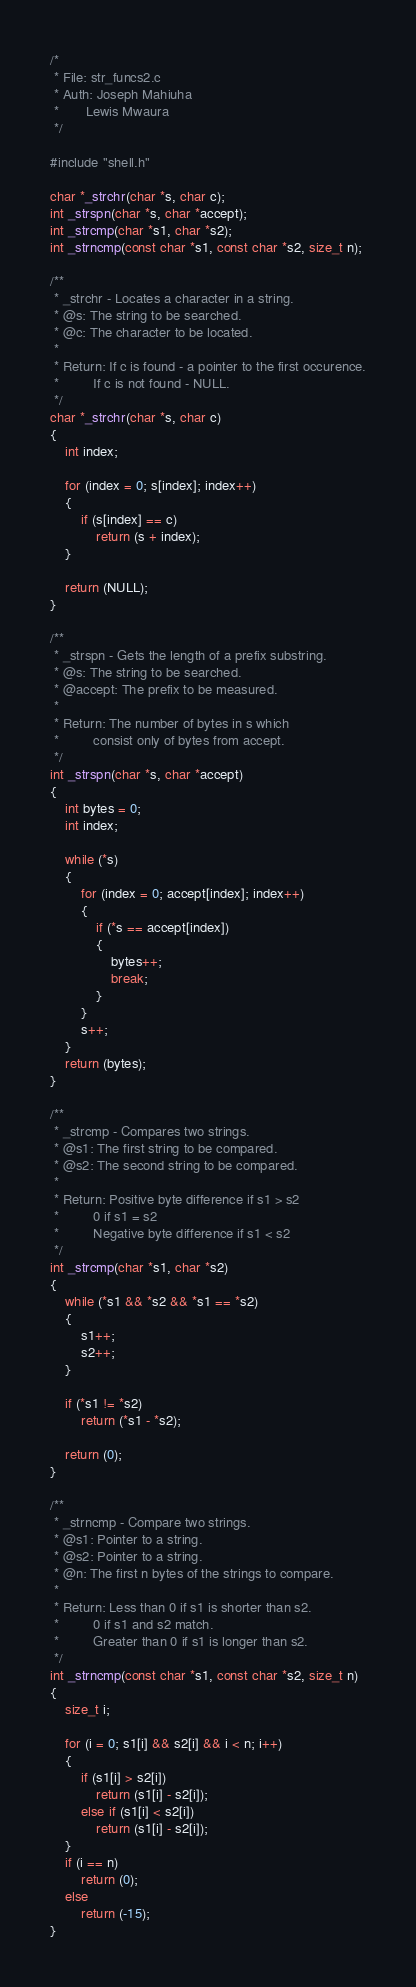<code> <loc_0><loc_0><loc_500><loc_500><_C_>/*
 * File: str_funcs2.c
 * Auth: Joseph Mahiuha
 *       Lewis Mwaura
 */

#include "shell.h"

char *_strchr(char *s, char c);
int _strspn(char *s, char *accept);
int _strcmp(char *s1, char *s2);
int _strncmp(const char *s1, const char *s2, size_t n);

/**
 * _strchr - Locates a character in a string.
 * @s: The string to be searched.
 * @c: The character to be located.
 *
 * Return: If c is found - a pointer to the first occurence.
 *         If c is not found - NULL.
 */
char *_strchr(char *s, char c)
{
	int index;

	for (index = 0; s[index]; index++)
	{
		if (s[index] == c)
			return (s + index);
	}

	return (NULL);
}

/**
 * _strspn - Gets the length of a prefix substring.
 * @s: The string to be searched.
 * @accept: The prefix to be measured.
 *
 * Return: The number of bytes in s which
 *         consist only of bytes from accept.
 */
int _strspn(char *s, char *accept)
{
	int bytes = 0;
	int index;

	while (*s)
	{
		for (index = 0; accept[index]; index++)
		{
			if (*s == accept[index])
			{
				bytes++;
				break;
			}
		}
		s++;
	}
	return (bytes);
}

/**
 * _strcmp - Compares two strings.
 * @s1: The first string to be compared.
 * @s2: The second string to be compared.
 *
 * Return: Positive byte difference if s1 > s2
 *         0 if s1 = s2
 *         Negative byte difference if s1 < s2
 */
int _strcmp(char *s1, char *s2)
{
	while (*s1 && *s2 && *s1 == *s2)
	{
		s1++;
		s2++;
	}

	if (*s1 != *s2)
		return (*s1 - *s2);

	return (0);
}

/**
 * _strncmp - Compare two strings.
 * @s1: Pointer to a string.
 * @s2: Pointer to a string.
 * @n: The first n bytes of the strings to compare.
 *
 * Return: Less than 0 if s1 is shorter than s2.
 *         0 if s1 and s2 match.
 *         Greater than 0 if s1 is longer than s2.
 */
int _strncmp(const char *s1, const char *s2, size_t n)
{
	size_t i;

	for (i = 0; s1[i] && s2[i] && i < n; i++)
	{
		if (s1[i] > s2[i])
			return (s1[i] - s2[i]);
		else if (s1[i] < s2[i])
			return (s1[i] - s2[i]);
	}
	if (i == n)
		return (0);
	else
		return (-15);
}
</code> 